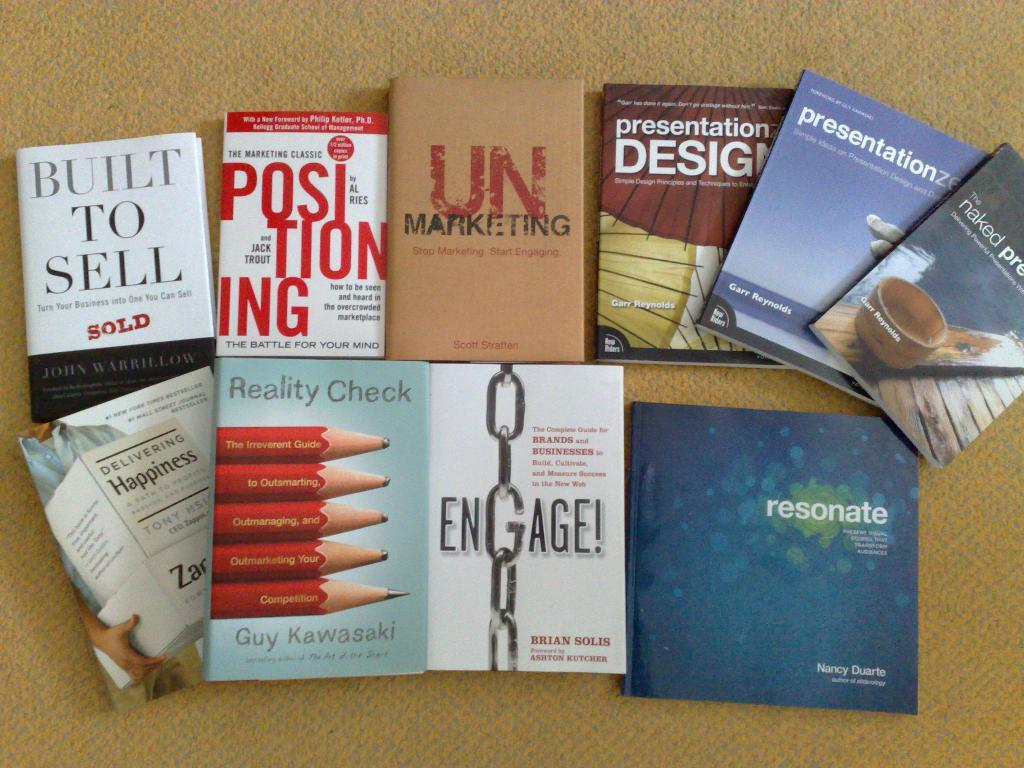<image>
Create a compact narrative representing the image presented. brown background with ten books on it with titles such as unmarketing and built to sell 